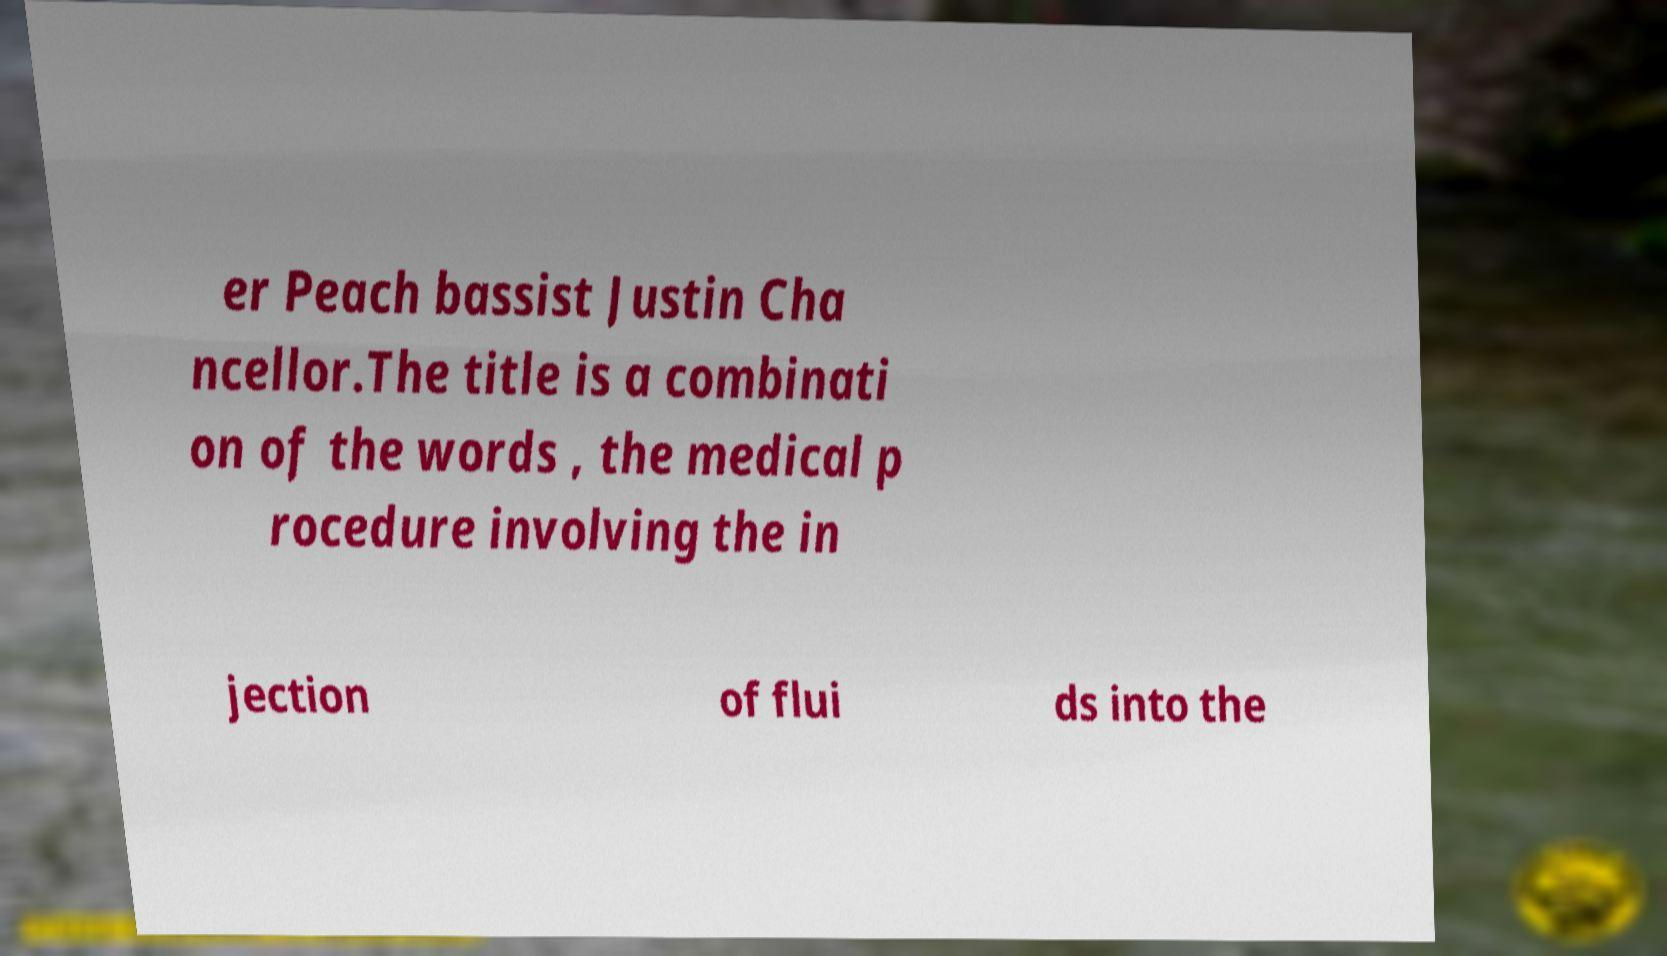Could you assist in decoding the text presented in this image and type it out clearly? er Peach bassist Justin Cha ncellor.The title is a combinati on of the words , the medical p rocedure involving the in jection of flui ds into the 